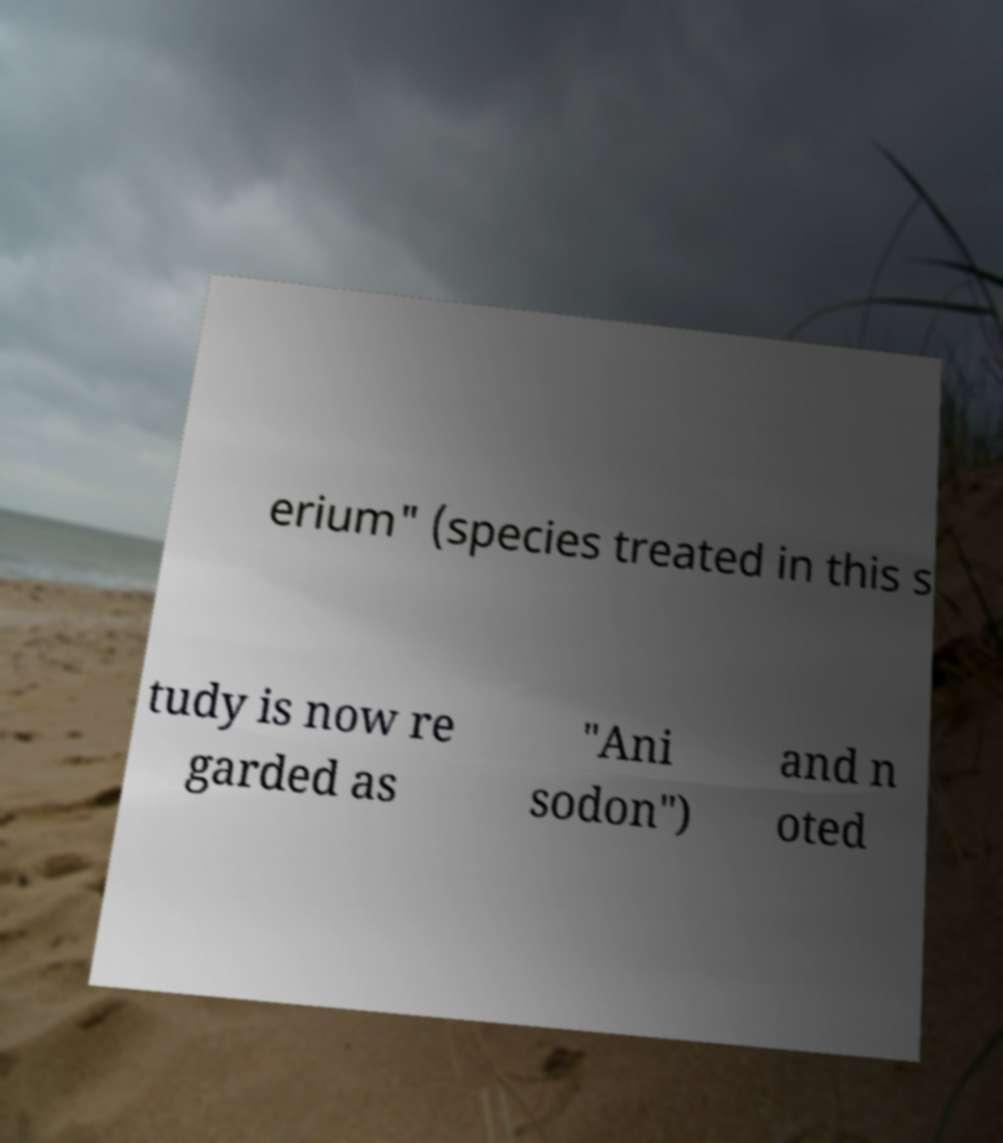I need the written content from this picture converted into text. Can you do that? erium" (species treated in this s tudy is now re garded as "Ani sodon") and n oted 